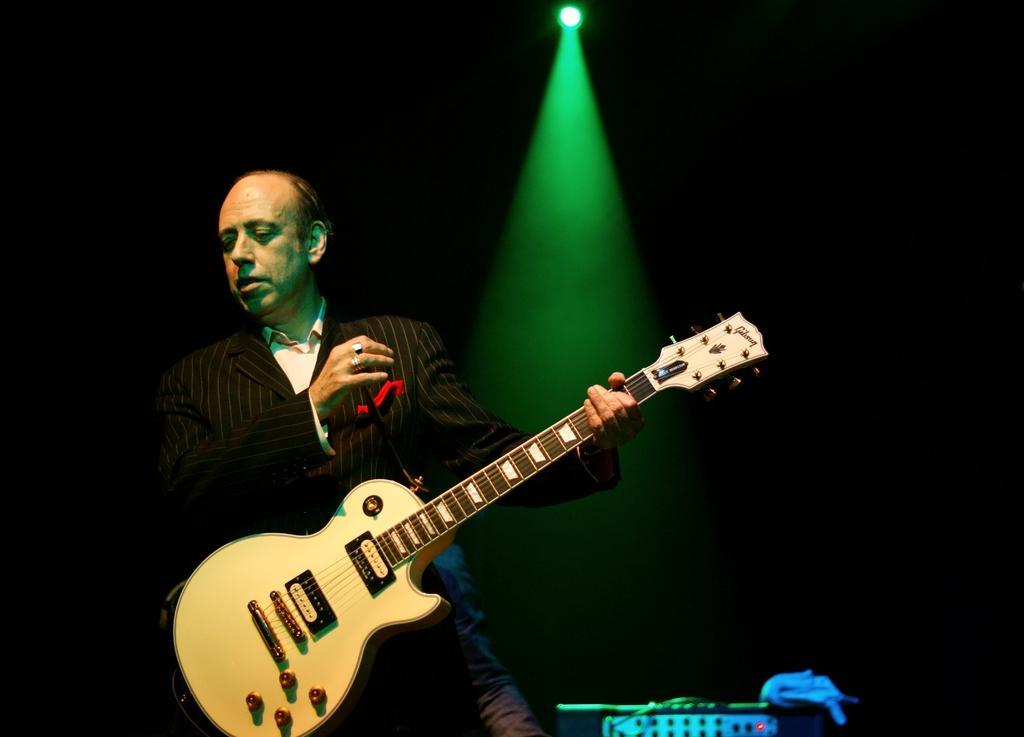Could you give a brief overview of what you see in this image? In this image I can see a man wearing black color suit, standing and holding a guitar in his hand. On the top of the image there is a light. On the bottom of the image I can see a box. 